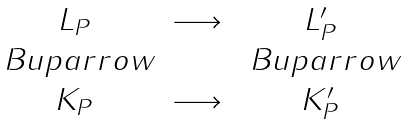Convert formula to latex. <formula><loc_0><loc_0><loc_500><loc_500>\begin{matrix} L _ { P } & \longrightarrow & L _ { P } ^ { \prime } \\ \ B u p a r r o w & & \ B u p a r r o w \\ K _ { P } & \longrightarrow & K _ { P } ^ { \prime } \end{matrix}</formula> 